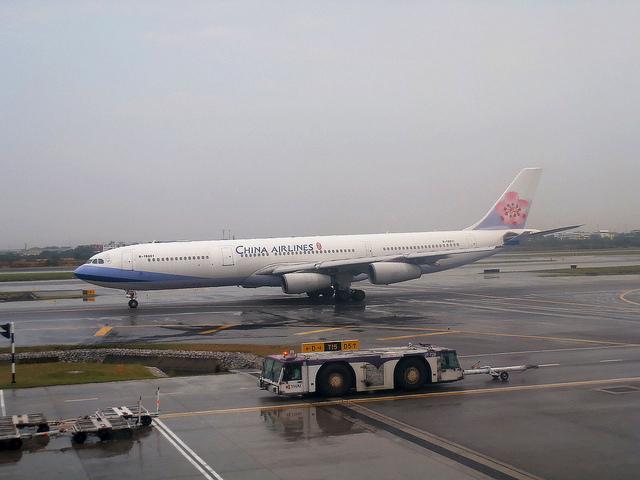What country did this airplane originate in?
Give a very brief answer. China. Is the sky blue?
Concise answer only. No. Why was this picture taken?
Be succinct. To see plane. Is the ground wet?
Write a very short answer. Yes. What type of plane is that?
Keep it brief. Passenger. 